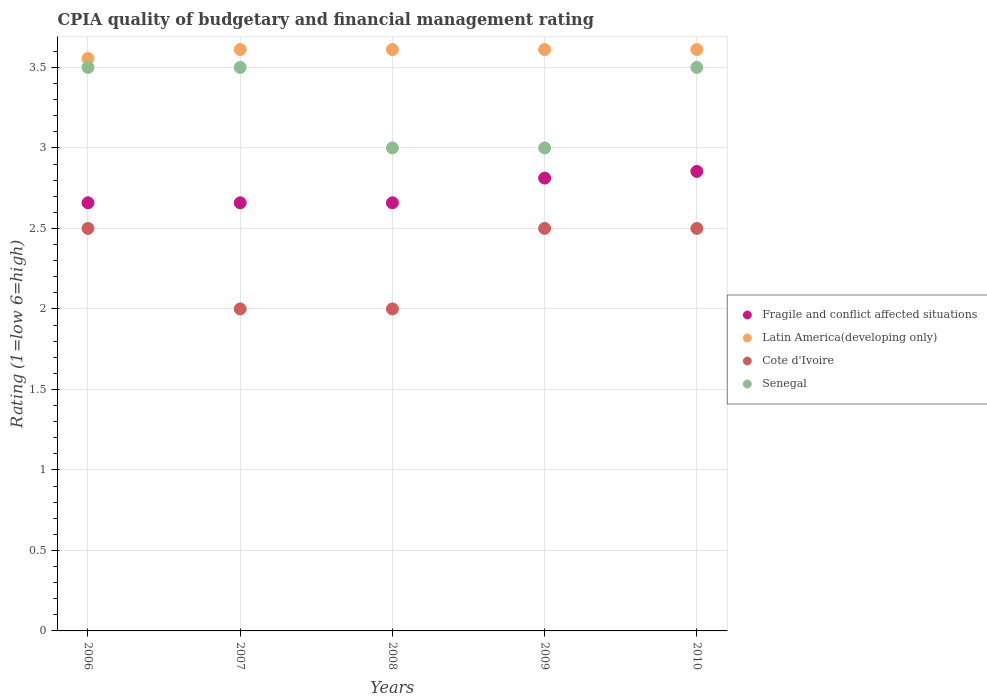How many different coloured dotlines are there?
Your answer should be compact. 4. Is the number of dotlines equal to the number of legend labels?
Your answer should be very brief. Yes. What is the CPIA rating in Latin America(developing only) in 2009?
Offer a terse response. 3.61. Across all years, what is the maximum CPIA rating in Senegal?
Your response must be concise. 3.5. Across all years, what is the minimum CPIA rating in Fragile and conflict affected situations?
Make the answer very short. 2.66. In which year was the CPIA rating in Senegal maximum?
Your answer should be compact. 2006. In which year was the CPIA rating in Cote d'Ivoire minimum?
Your answer should be very brief. 2007. What is the difference between the CPIA rating in Senegal in 2007 and that in 2009?
Your response must be concise. 0.5. What is the difference between the CPIA rating in Senegal in 2009 and the CPIA rating in Cote d'Ivoire in 2008?
Your answer should be compact. 1. What is the average CPIA rating in Fragile and conflict affected situations per year?
Provide a succinct answer. 2.73. In how many years, is the CPIA rating in Fragile and conflict affected situations greater than 2.8?
Ensure brevity in your answer.  2. What is the ratio of the CPIA rating in Fragile and conflict affected situations in 2007 to that in 2010?
Provide a succinct answer. 0.93. Is the CPIA rating in Senegal in 2006 less than that in 2009?
Ensure brevity in your answer.  No. What is the difference between the highest and the second highest CPIA rating in Latin America(developing only)?
Your response must be concise. 0. What is the difference between the highest and the lowest CPIA rating in Fragile and conflict affected situations?
Offer a terse response. 0.2. Is the sum of the CPIA rating in Cote d'Ivoire in 2007 and 2009 greater than the maximum CPIA rating in Latin America(developing only) across all years?
Your answer should be compact. Yes. Does the CPIA rating in Senegal monotonically increase over the years?
Provide a succinct answer. No. Is the CPIA rating in Fragile and conflict affected situations strictly greater than the CPIA rating in Senegal over the years?
Offer a terse response. No. How many dotlines are there?
Provide a succinct answer. 4. What is the difference between two consecutive major ticks on the Y-axis?
Your answer should be compact. 0.5. Does the graph contain any zero values?
Give a very brief answer. No. How many legend labels are there?
Offer a terse response. 4. What is the title of the graph?
Your answer should be very brief. CPIA quality of budgetary and financial management rating. Does "Madagascar" appear as one of the legend labels in the graph?
Your answer should be very brief. No. What is the label or title of the Y-axis?
Your answer should be compact. Rating (1=low 6=high). What is the Rating (1=low 6=high) in Fragile and conflict affected situations in 2006?
Offer a very short reply. 2.66. What is the Rating (1=low 6=high) of Latin America(developing only) in 2006?
Your answer should be compact. 3.56. What is the Rating (1=low 6=high) in Senegal in 2006?
Provide a short and direct response. 3.5. What is the Rating (1=low 6=high) of Fragile and conflict affected situations in 2007?
Keep it short and to the point. 2.66. What is the Rating (1=low 6=high) in Latin America(developing only) in 2007?
Your answer should be compact. 3.61. What is the Rating (1=low 6=high) in Senegal in 2007?
Ensure brevity in your answer.  3.5. What is the Rating (1=low 6=high) in Fragile and conflict affected situations in 2008?
Your response must be concise. 2.66. What is the Rating (1=low 6=high) in Latin America(developing only) in 2008?
Offer a very short reply. 3.61. What is the Rating (1=low 6=high) in Cote d'Ivoire in 2008?
Offer a terse response. 2. What is the Rating (1=low 6=high) in Senegal in 2008?
Keep it short and to the point. 3. What is the Rating (1=low 6=high) in Fragile and conflict affected situations in 2009?
Your answer should be very brief. 2.81. What is the Rating (1=low 6=high) in Latin America(developing only) in 2009?
Provide a short and direct response. 3.61. What is the Rating (1=low 6=high) in Cote d'Ivoire in 2009?
Give a very brief answer. 2.5. What is the Rating (1=low 6=high) in Senegal in 2009?
Keep it short and to the point. 3. What is the Rating (1=low 6=high) in Fragile and conflict affected situations in 2010?
Offer a very short reply. 2.85. What is the Rating (1=low 6=high) in Latin America(developing only) in 2010?
Make the answer very short. 3.61. Across all years, what is the maximum Rating (1=low 6=high) in Fragile and conflict affected situations?
Give a very brief answer. 2.85. Across all years, what is the maximum Rating (1=low 6=high) of Latin America(developing only)?
Your answer should be compact. 3.61. Across all years, what is the maximum Rating (1=low 6=high) of Cote d'Ivoire?
Provide a succinct answer. 2.5. Across all years, what is the minimum Rating (1=low 6=high) of Fragile and conflict affected situations?
Ensure brevity in your answer.  2.66. Across all years, what is the minimum Rating (1=low 6=high) in Latin America(developing only)?
Give a very brief answer. 3.56. Across all years, what is the minimum Rating (1=low 6=high) of Senegal?
Keep it short and to the point. 3. What is the total Rating (1=low 6=high) of Fragile and conflict affected situations in the graph?
Provide a succinct answer. 13.64. What is the total Rating (1=low 6=high) of Cote d'Ivoire in the graph?
Offer a terse response. 11.5. What is the difference between the Rating (1=low 6=high) in Latin America(developing only) in 2006 and that in 2007?
Ensure brevity in your answer.  -0.06. What is the difference between the Rating (1=low 6=high) in Cote d'Ivoire in 2006 and that in 2007?
Ensure brevity in your answer.  0.5. What is the difference between the Rating (1=low 6=high) in Senegal in 2006 and that in 2007?
Your answer should be very brief. 0. What is the difference between the Rating (1=low 6=high) of Latin America(developing only) in 2006 and that in 2008?
Give a very brief answer. -0.06. What is the difference between the Rating (1=low 6=high) in Senegal in 2006 and that in 2008?
Provide a short and direct response. 0.5. What is the difference between the Rating (1=low 6=high) in Fragile and conflict affected situations in 2006 and that in 2009?
Ensure brevity in your answer.  -0.15. What is the difference between the Rating (1=low 6=high) in Latin America(developing only) in 2006 and that in 2009?
Offer a terse response. -0.06. What is the difference between the Rating (1=low 6=high) in Cote d'Ivoire in 2006 and that in 2009?
Your answer should be compact. 0. What is the difference between the Rating (1=low 6=high) in Fragile and conflict affected situations in 2006 and that in 2010?
Keep it short and to the point. -0.2. What is the difference between the Rating (1=low 6=high) in Latin America(developing only) in 2006 and that in 2010?
Your answer should be compact. -0.06. What is the difference between the Rating (1=low 6=high) of Cote d'Ivoire in 2007 and that in 2008?
Provide a succinct answer. 0. What is the difference between the Rating (1=low 6=high) in Senegal in 2007 and that in 2008?
Offer a very short reply. 0.5. What is the difference between the Rating (1=low 6=high) of Fragile and conflict affected situations in 2007 and that in 2009?
Provide a succinct answer. -0.15. What is the difference between the Rating (1=low 6=high) of Cote d'Ivoire in 2007 and that in 2009?
Offer a very short reply. -0.5. What is the difference between the Rating (1=low 6=high) of Senegal in 2007 and that in 2009?
Your answer should be compact. 0.5. What is the difference between the Rating (1=low 6=high) in Fragile and conflict affected situations in 2007 and that in 2010?
Your answer should be compact. -0.2. What is the difference between the Rating (1=low 6=high) of Senegal in 2007 and that in 2010?
Give a very brief answer. 0. What is the difference between the Rating (1=low 6=high) of Fragile and conflict affected situations in 2008 and that in 2009?
Your response must be concise. -0.15. What is the difference between the Rating (1=low 6=high) of Latin America(developing only) in 2008 and that in 2009?
Keep it short and to the point. 0. What is the difference between the Rating (1=low 6=high) of Senegal in 2008 and that in 2009?
Your answer should be very brief. 0. What is the difference between the Rating (1=low 6=high) in Fragile and conflict affected situations in 2008 and that in 2010?
Your answer should be compact. -0.2. What is the difference between the Rating (1=low 6=high) in Senegal in 2008 and that in 2010?
Your answer should be compact. -0.5. What is the difference between the Rating (1=low 6=high) of Fragile and conflict affected situations in 2009 and that in 2010?
Your answer should be very brief. -0.04. What is the difference between the Rating (1=low 6=high) in Latin America(developing only) in 2009 and that in 2010?
Your answer should be compact. 0. What is the difference between the Rating (1=low 6=high) of Senegal in 2009 and that in 2010?
Provide a succinct answer. -0.5. What is the difference between the Rating (1=low 6=high) in Fragile and conflict affected situations in 2006 and the Rating (1=low 6=high) in Latin America(developing only) in 2007?
Ensure brevity in your answer.  -0.95. What is the difference between the Rating (1=low 6=high) in Fragile and conflict affected situations in 2006 and the Rating (1=low 6=high) in Cote d'Ivoire in 2007?
Ensure brevity in your answer.  0.66. What is the difference between the Rating (1=low 6=high) in Fragile and conflict affected situations in 2006 and the Rating (1=low 6=high) in Senegal in 2007?
Your response must be concise. -0.84. What is the difference between the Rating (1=low 6=high) in Latin America(developing only) in 2006 and the Rating (1=low 6=high) in Cote d'Ivoire in 2007?
Keep it short and to the point. 1.56. What is the difference between the Rating (1=low 6=high) of Latin America(developing only) in 2006 and the Rating (1=low 6=high) of Senegal in 2007?
Offer a very short reply. 0.06. What is the difference between the Rating (1=low 6=high) in Cote d'Ivoire in 2006 and the Rating (1=low 6=high) in Senegal in 2007?
Your answer should be very brief. -1. What is the difference between the Rating (1=low 6=high) of Fragile and conflict affected situations in 2006 and the Rating (1=low 6=high) of Latin America(developing only) in 2008?
Keep it short and to the point. -0.95. What is the difference between the Rating (1=low 6=high) in Fragile and conflict affected situations in 2006 and the Rating (1=low 6=high) in Cote d'Ivoire in 2008?
Make the answer very short. 0.66. What is the difference between the Rating (1=low 6=high) of Fragile and conflict affected situations in 2006 and the Rating (1=low 6=high) of Senegal in 2008?
Your response must be concise. -0.34. What is the difference between the Rating (1=low 6=high) of Latin America(developing only) in 2006 and the Rating (1=low 6=high) of Cote d'Ivoire in 2008?
Your answer should be very brief. 1.56. What is the difference between the Rating (1=low 6=high) in Latin America(developing only) in 2006 and the Rating (1=low 6=high) in Senegal in 2008?
Make the answer very short. 0.56. What is the difference between the Rating (1=low 6=high) in Cote d'Ivoire in 2006 and the Rating (1=low 6=high) in Senegal in 2008?
Provide a short and direct response. -0.5. What is the difference between the Rating (1=low 6=high) in Fragile and conflict affected situations in 2006 and the Rating (1=low 6=high) in Latin America(developing only) in 2009?
Keep it short and to the point. -0.95. What is the difference between the Rating (1=low 6=high) of Fragile and conflict affected situations in 2006 and the Rating (1=low 6=high) of Cote d'Ivoire in 2009?
Provide a succinct answer. 0.16. What is the difference between the Rating (1=low 6=high) in Fragile and conflict affected situations in 2006 and the Rating (1=low 6=high) in Senegal in 2009?
Your answer should be compact. -0.34. What is the difference between the Rating (1=low 6=high) in Latin America(developing only) in 2006 and the Rating (1=low 6=high) in Cote d'Ivoire in 2009?
Offer a terse response. 1.06. What is the difference between the Rating (1=low 6=high) in Latin America(developing only) in 2006 and the Rating (1=low 6=high) in Senegal in 2009?
Your answer should be compact. 0.56. What is the difference between the Rating (1=low 6=high) of Fragile and conflict affected situations in 2006 and the Rating (1=low 6=high) of Latin America(developing only) in 2010?
Give a very brief answer. -0.95. What is the difference between the Rating (1=low 6=high) of Fragile and conflict affected situations in 2006 and the Rating (1=low 6=high) of Cote d'Ivoire in 2010?
Offer a very short reply. 0.16. What is the difference between the Rating (1=low 6=high) in Fragile and conflict affected situations in 2006 and the Rating (1=low 6=high) in Senegal in 2010?
Your response must be concise. -0.84. What is the difference between the Rating (1=low 6=high) in Latin America(developing only) in 2006 and the Rating (1=low 6=high) in Cote d'Ivoire in 2010?
Ensure brevity in your answer.  1.06. What is the difference between the Rating (1=low 6=high) of Latin America(developing only) in 2006 and the Rating (1=low 6=high) of Senegal in 2010?
Ensure brevity in your answer.  0.06. What is the difference between the Rating (1=low 6=high) of Cote d'Ivoire in 2006 and the Rating (1=low 6=high) of Senegal in 2010?
Your answer should be very brief. -1. What is the difference between the Rating (1=low 6=high) of Fragile and conflict affected situations in 2007 and the Rating (1=low 6=high) of Latin America(developing only) in 2008?
Your answer should be very brief. -0.95. What is the difference between the Rating (1=low 6=high) of Fragile and conflict affected situations in 2007 and the Rating (1=low 6=high) of Cote d'Ivoire in 2008?
Keep it short and to the point. 0.66. What is the difference between the Rating (1=low 6=high) in Fragile and conflict affected situations in 2007 and the Rating (1=low 6=high) in Senegal in 2008?
Give a very brief answer. -0.34. What is the difference between the Rating (1=low 6=high) in Latin America(developing only) in 2007 and the Rating (1=low 6=high) in Cote d'Ivoire in 2008?
Offer a terse response. 1.61. What is the difference between the Rating (1=low 6=high) in Latin America(developing only) in 2007 and the Rating (1=low 6=high) in Senegal in 2008?
Provide a short and direct response. 0.61. What is the difference between the Rating (1=low 6=high) in Cote d'Ivoire in 2007 and the Rating (1=low 6=high) in Senegal in 2008?
Give a very brief answer. -1. What is the difference between the Rating (1=low 6=high) of Fragile and conflict affected situations in 2007 and the Rating (1=low 6=high) of Latin America(developing only) in 2009?
Give a very brief answer. -0.95. What is the difference between the Rating (1=low 6=high) of Fragile and conflict affected situations in 2007 and the Rating (1=low 6=high) of Cote d'Ivoire in 2009?
Provide a succinct answer. 0.16. What is the difference between the Rating (1=low 6=high) of Fragile and conflict affected situations in 2007 and the Rating (1=low 6=high) of Senegal in 2009?
Give a very brief answer. -0.34. What is the difference between the Rating (1=low 6=high) of Latin America(developing only) in 2007 and the Rating (1=low 6=high) of Cote d'Ivoire in 2009?
Ensure brevity in your answer.  1.11. What is the difference between the Rating (1=low 6=high) of Latin America(developing only) in 2007 and the Rating (1=low 6=high) of Senegal in 2009?
Provide a succinct answer. 0.61. What is the difference between the Rating (1=low 6=high) of Cote d'Ivoire in 2007 and the Rating (1=low 6=high) of Senegal in 2009?
Provide a succinct answer. -1. What is the difference between the Rating (1=low 6=high) in Fragile and conflict affected situations in 2007 and the Rating (1=low 6=high) in Latin America(developing only) in 2010?
Ensure brevity in your answer.  -0.95. What is the difference between the Rating (1=low 6=high) of Fragile and conflict affected situations in 2007 and the Rating (1=low 6=high) of Cote d'Ivoire in 2010?
Keep it short and to the point. 0.16. What is the difference between the Rating (1=low 6=high) of Fragile and conflict affected situations in 2007 and the Rating (1=low 6=high) of Senegal in 2010?
Make the answer very short. -0.84. What is the difference between the Rating (1=low 6=high) of Latin America(developing only) in 2007 and the Rating (1=low 6=high) of Senegal in 2010?
Provide a short and direct response. 0.11. What is the difference between the Rating (1=low 6=high) of Fragile and conflict affected situations in 2008 and the Rating (1=low 6=high) of Latin America(developing only) in 2009?
Your answer should be compact. -0.95. What is the difference between the Rating (1=low 6=high) in Fragile and conflict affected situations in 2008 and the Rating (1=low 6=high) in Cote d'Ivoire in 2009?
Keep it short and to the point. 0.16. What is the difference between the Rating (1=low 6=high) of Fragile and conflict affected situations in 2008 and the Rating (1=low 6=high) of Senegal in 2009?
Your response must be concise. -0.34. What is the difference between the Rating (1=low 6=high) of Latin America(developing only) in 2008 and the Rating (1=low 6=high) of Cote d'Ivoire in 2009?
Offer a very short reply. 1.11. What is the difference between the Rating (1=low 6=high) of Latin America(developing only) in 2008 and the Rating (1=low 6=high) of Senegal in 2009?
Your response must be concise. 0.61. What is the difference between the Rating (1=low 6=high) in Cote d'Ivoire in 2008 and the Rating (1=low 6=high) in Senegal in 2009?
Your response must be concise. -1. What is the difference between the Rating (1=low 6=high) of Fragile and conflict affected situations in 2008 and the Rating (1=low 6=high) of Latin America(developing only) in 2010?
Your answer should be very brief. -0.95. What is the difference between the Rating (1=low 6=high) of Fragile and conflict affected situations in 2008 and the Rating (1=low 6=high) of Cote d'Ivoire in 2010?
Offer a terse response. 0.16. What is the difference between the Rating (1=low 6=high) of Fragile and conflict affected situations in 2008 and the Rating (1=low 6=high) of Senegal in 2010?
Provide a succinct answer. -0.84. What is the difference between the Rating (1=low 6=high) of Latin America(developing only) in 2008 and the Rating (1=low 6=high) of Senegal in 2010?
Your answer should be very brief. 0.11. What is the difference between the Rating (1=low 6=high) of Fragile and conflict affected situations in 2009 and the Rating (1=low 6=high) of Latin America(developing only) in 2010?
Provide a short and direct response. -0.8. What is the difference between the Rating (1=low 6=high) in Fragile and conflict affected situations in 2009 and the Rating (1=low 6=high) in Cote d'Ivoire in 2010?
Offer a terse response. 0.31. What is the difference between the Rating (1=low 6=high) in Fragile and conflict affected situations in 2009 and the Rating (1=low 6=high) in Senegal in 2010?
Your answer should be compact. -0.69. What is the difference between the Rating (1=low 6=high) in Latin America(developing only) in 2009 and the Rating (1=low 6=high) in Senegal in 2010?
Your answer should be compact. 0.11. What is the average Rating (1=low 6=high) of Fragile and conflict affected situations per year?
Your answer should be compact. 2.73. What is the average Rating (1=low 6=high) in Latin America(developing only) per year?
Keep it short and to the point. 3.6. What is the average Rating (1=low 6=high) in Cote d'Ivoire per year?
Offer a terse response. 2.3. What is the average Rating (1=low 6=high) of Senegal per year?
Offer a terse response. 3.3. In the year 2006, what is the difference between the Rating (1=low 6=high) in Fragile and conflict affected situations and Rating (1=low 6=high) in Latin America(developing only)?
Offer a terse response. -0.9. In the year 2006, what is the difference between the Rating (1=low 6=high) in Fragile and conflict affected situations and Rating (1=low 6=high) in Cote d'Ivoire?
Ensure brevity in your answer.  0.16. In the year 2006, what is the difference between the Rating (1=low 6=high) of Fragile and conflict affected situations and Rating (1=low 6=high) of Senegal?
Provide a succinct answer. -0.84. In the year 2006, what is the difference between the Rating (1=low 6=high) in Latin America(developing only) and Rating (1=low 6=high) in Cote d'Ivoire?
Keep it short and to the point. 1.06. In the year 2006, what is the difference between the Rating (1=low 6=high) of Latin America(developing only) and Rating (1=low 6=high) of Senegal?
Provide a short and direct response. 0.06. In the year 2007, what is the difference between the Rating (1=low 6=high) of Fragile and conflict affected situations and Rating (1=low 6=high) of Latin America(developing only)?
Your answer should be very brief. -0.95. In the year 2007, what is the difference between the Rating (1=low 6=high) in Fragile and conflict affected situations and Rating (1=low 6=high) in Cote d'Ivoire?
Keep it short and to the point. 0.66. In the year 2007, what is the difference between the Rating (1=low 6=high) of Fragile and conflict affected situations and Rating (1=low 6=high) of Senegal?
Your answer should be very brief. -0.84. In the year 2007, what is the difference between the Rating (1=low 6=high) in Latin America(developing only) and Rating (1=low 6=high) in Cote d'Ivoire?
Your response must be concise. 1.61. In the year 2007, what is the difference between the Rating (1=low 6=high) in Cote d'Ivoire and Rating (1=low 6=high) in Senegal?
Keep it short and to the point. -1.5. In the year 2008, what is the difference between the Rating (1=low 6=high) of Fragile and conflict affected situations and Rating (1=low 6=high) of Latin America(developing only)?
Give a very brief answer. -0.95. In the year 2008, what is the difference between the Rating (1=low 6=high) in Fragile and conflict affected situations and Rating (1=low 6=high) in Cote d'Ivoire?
Make the answer very short. 0.66. In the year 2008, what is the difference between the Rating (1=low 6=high) of Fragile and conflict affected situations and Rating (1=low 6=high) of Senegal?
Give a very brief answer. -0.34. In the year 2008, what is the difference between the Rating (1=low 6=high) of Latin America(developing only) and Rating (1=low 6=high) of Cote d'Ivoire?
Make the answer very short. 1.61. In the year 2008, what is the difference between the Rating (1=low 6=high) of Latin America(developing only) and Rating (1=low 6=high) of Senegal?
Offer a very short reply. 0.61. In the year 2008, what is the difference between the Rating (1=low 6=high) in Cote d'Ivoire and Rating (1=low 6=high) in Senegal?
Your answer should be compact. -1. In the year 2009, what is the difference between the Rating (1=low 6=high) of Fragile and conflict affected situations and Rating (1=low 6=high) of Latin America(developing only)?
Your response must be concise. -0.8. In the year 2009, what is the difference between the Rating (1=low 6=high) of Fragile and conflict affected situations and Rating (1=low 6=high) of Cote d'Ivoire?
Offer a very short reply. 0.31. In the year 2009, what is the difference between the Rating (1=low 6=high) in Fragile and conflict affected situations and Rating (1=low 6=high) in Senegal?
Your answer should be compact. -0.19. In the year 2009, what is the difference between the Rating (1=low 6=high) of Latin America(developing only) and Rating (1=low 6=high) of Senegal?
Provide a short and direct response. 0.61. In the year 2009, what is the difference between the Rating (1=low 6=high) of Cote d'Ivoire and Rating (1=low 6=high) of Senegal?
Your answer should be compact. -0.5. In the year 2010, what is the difference between the Rating (1=low 6=high) of Fragile and conflict affected situations and Rating (1=low 6=high) of Latin America(developing only)?
Your response must be concise. -0.76. In the year 2010, what is the difference between the Rating (1=low 6=high) in Fragile and conflict affected situations and Rating (1=low 6=high) in Cote d'Ivoire?
Keep it short and to the point. 0.35. In the year 2010, what is the difference between the Rating (1=low 6=high) in Fragile and conflict affected situations and Rating (1=low 6=high) in Senegal?
Ensure brevity in your answer.  -0.65. In the year 2010, what is the difference between the Rating (1=low 6=high) of Latin America(developing only) and Rating (1=low 6=high) of Senegal?
Keep it short and to the point. 0.11. In the year 2010, what is the difference between the Rating (1=low 6=high) of Cote d'Ivoire and Rating (1=low 6=high) of Senegal?
Offer a terse response. -1. What is the ratio of the Rating (1=low 6=high) in Latin America(developing only) in 2006 to that in 2007?
Your response must be concise. 0.98. What is the ratio of the Rating (1=low 6=high) in Cote d'Ivoire in 2006 to that in 2007?
Give a very brief answer. 1.25. What is the ratio of the Rating (1=low 6=high) of Senegal in 2006 to that in 2007?
Provide a short and direct response. 1. What is the ratio of the Rating (1=low 6=high) in Latin America(developing only) in 2006 to that in 2008?
Offer a very short reply. 0.98. What is the ratio of the Rating (1=low 6=high) in Fragile and conflict affected situations in 2006 to that in 2009?
Make the answer very short. 0.95. What is the ratio of the Rating (1=low 6=high) of Latin America(developing only) in 2006 to that in 2009?
Your answer should be compact. 0.98. What is the ratio of the Rating (1=low 6=high) in Cote d'Ivoire in 2006 to that in 2009?
Your answer should be compact. 1. What is the ratio of the Rating (1=low 6=high) of Fragile and conflict affected situations in 2006 to that in 2010?
Your answer should be compact. 0.93. What is the ratio of the Rating (1=low 6=high) in Latin America(developing only) in 2006 to that in 2010?
Offer a terse response. 0.98. What is the ratio of the Rating (1=low 6=high) of Cote d'Ivoire in 2006 to that in 2010?
Provide a succinct answer. 1. What is the ratio of the Rating (1=low 6=high) of Fragile and conflict affected situations in 2007 to that in 2008?
Ensure brevity in your answer.  1. What is the ratio of the Rating (1=low 6=high) in Cote d'Ivoire in 2007 to that in 2008?
Your answer should be very brief. 1. What is the ratio of the Rating (1=low 6=high) in Senegal in 2007 to that in 2008?
Provide a short and direct response. 1.17. What is the ratio of the Rating (1=low 6=high) in Fragile and conflict affected situations in 2007 to that in 2009?
Offer a terse response. 0.95. What is the ratio of the Rating (1=low 6=high) of Fragile and conflict affected situations in 2007 to that in 2010?
Ensure brevity in your answer.  0.93. What is the ratio of the Rating (1=low 6=high) in Senegal in 2007 to that in 2010?
Give a very brief answer. 1. What is the ratio of the Rating (1=low 6=high) of Fragile and conflict affected situations in 2008 to that in 2009?
Provide a succinct answer. 0.95. What is the ratio of the Rating (1=low 6=high) of Latin America(developing only) in 2008 to that in 2009?
Keep it short and to the point. 1. What is the ratio of the Rating (1=low 6=high) in Senegal in 2008 to that in 2009?
Make the answer very short. 1. What is the ratio of the Rating (1=low 6=high) in Fragile and conflict affected situations in 2008 to that in 2010?
Offer a terse response. 0.93. What is the ratio of the Rating (1=low 6=high) in Latin America(developing only) in 2008 to that in 2010?
Make the answer very short. 1. What is the ratio of the Rating (1=low 6=high) in Senegal in 2008 to that in 2010?
Make the answer very short. 0.86. What is the ratio of the Rating (1=low 6=high) of Fragile and conflict affected situations in 2009 to that in 2010?
Your answer should be very brief. 0.99. What is the ratio of the Rating (1=low 6=high) of Latin America(developing only) in 2009 to that in 2010?
Give a very brief answer. 1. What is the ratio of the Rating (1=low 6=high) in Senegal in 2009 to that in 2010?
Provide a succinct answer. 0.86. What is the difference between the highest and the second highest Rating (1=low 6=high) in Fragile and conflict affected situations?
Make the answer very short. 0.04. What is the difference between the highest and the second highest Rating (1=low 6=high) of Latin America(developing only)?
Provide a short and direct response. 0. What is the difference between the highest and the second highest Rating (1=low 6=high) in Senegal?
Make the answer very short. 0. What is the difference between the highest and the lowest Rating (1=low 6=high) of Fragile and conflict affected situations?
Offer a very short reply. 0.2. What is the difference between the highest and the lowest Rating (1=low 6=high) of Latin America(developing only)?
Offer a terse response. 0.06. What is the difference between the highest and the lowest Rating (1=low 6=high) in Cote d'Ivoire?
Provide a short and direct response. 0.5. 